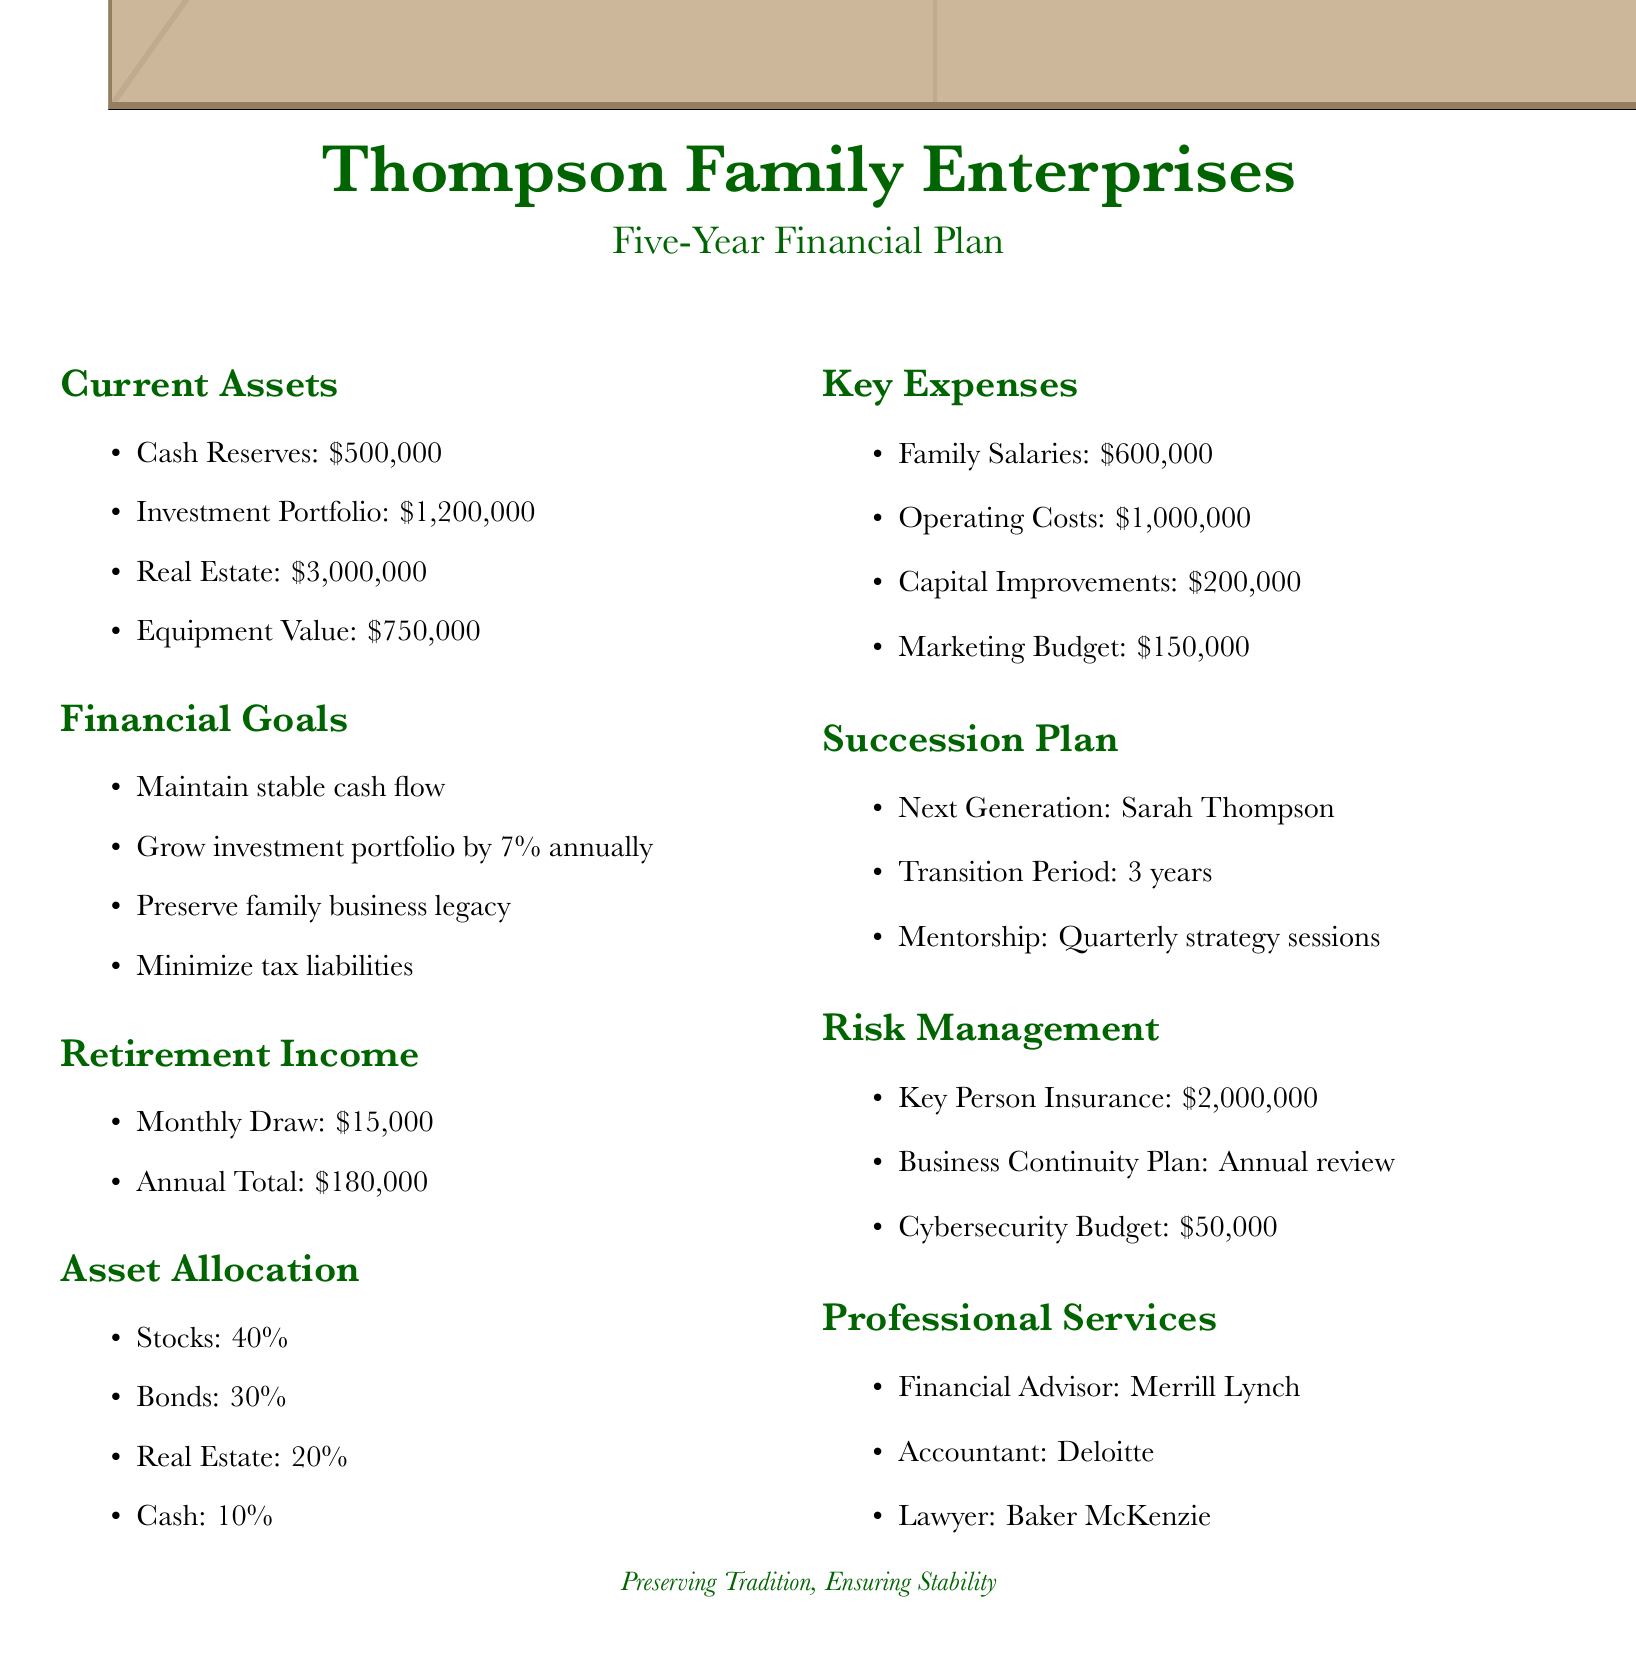What is the total cash reserves? The cash reserves listed in the document is $500,000.
Answer: $500,000 Who is the next generation for succession? The next generation named in the document is Sarah Thompson.
Answer: Sarah Thompson What is the annual total of retirement income? The annual total mentioned for retirement income is $180,000.
Answer: $180,000 What percentage of the asset allocation is in bonds? The document states that the bond allocation is 30%.
Answer: 30% What is the marketing budget? The budget allocated for marketing in the document is $150,000.
Answer: $150,000 How often will mentorship occur during the transition period? The mentorship sessions will occur quarterly, according to the document.
Answer: Quarterly What is the estimated growth rate of the investment portfolio? The document specifies a growth rate of 7% annually for the investment portfolio.
Answer: 7% What is the key person insurance amount? The key person insurance amount stated in the document is $2,000,000.
Answer: $2,000,000 What are the family salaries listed in the key expenses? The family salaries in the document total $600,000.
Answer: $600,000 